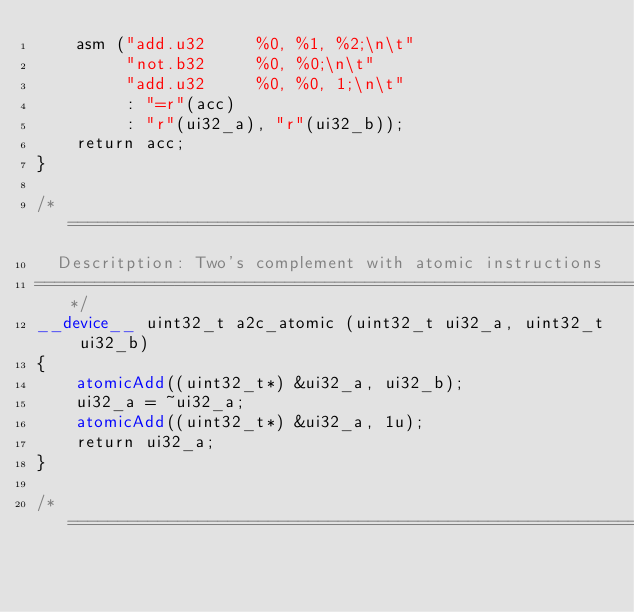Convert code to text. <code><loc_0><loc_0><loc_500><loc_500><_Cuda_>    asm ("add.u32     %0, %1, %2;\n\t"
         "not.b32     %0, %0;\n\t"
         "add.u32     %0, %0, 1;\n\t"
         : "=r"(acc)
         : "r"(ui32_a), "r"(ui32_b));
    return acc;
}

/* ==========================================================================
  Descritption: Two's complement with atomic instructions
=============================================================================*/
__device__ uint32_t a2c_atomic (uint32_t ui32_a, uint32_t ui32_b)
{
    atomicAdd((uint32_t*) &ui32_a, ui32_b);
    ui32_a = ~ui32_a;
    atomicAdd((uint32_t*) &ui32_a, 1u);
    return ui32_a;
}

/* ==========================================================================</code> 